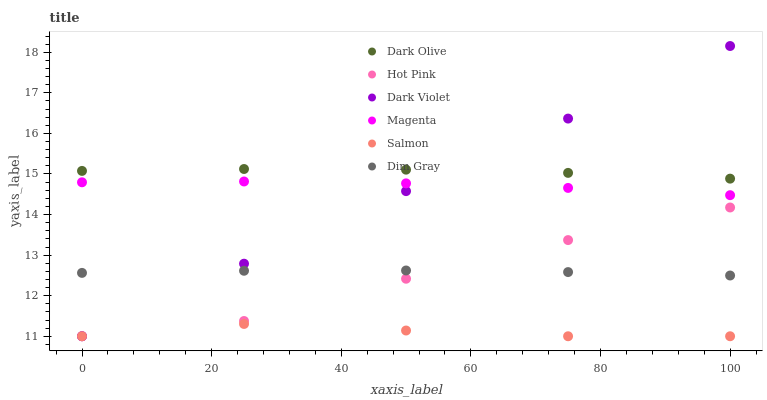Does Salmon have the minimum area under the curve?
Answer yes or no. Yes. Does Dark Olive have the maximum area under the curve?
Answer yes or no. Yes. Does Dark Olive have the minimum area under the curve?
Answer yes or no. No. Does Salmon have the maximum area under the curve?
Answer yes or no. No. Is Dark Violet the smoothest?
Answer yes or no. Yes. Is Hot Pink the roughest?
Answer yes or no. Yes. Is Dark Olive the smoothest?
Answer yes or no. No. Is Dark Olive the roughest?
Answer yes or no. No. Does Salmon have the lowest value?
Answer yes or no. Yes. Does Dark Olive have the lowest value?
Answer yes or no. No. Does Dark Violet have the highest value?
Answer yes or no. Yes. Does Dark Olive have the highest value?
Answer yes or no. No. Is Magenta less than Dark Olive?
Answer yes or no. Yes. Is Dark Olive greater than Dim Gray?
Answer yes or no. Yes. Does Dark Olive intersect Dark Violet?
Answer yes or no. Yes. Is Dark Olive less than Dark Violet?
Answer yes or no. No. Is Dark Olive greater than Dark Violet?
Answer yes or no. No. Does Magenta intersect Dark Olive?
Answer yes or no. No. 